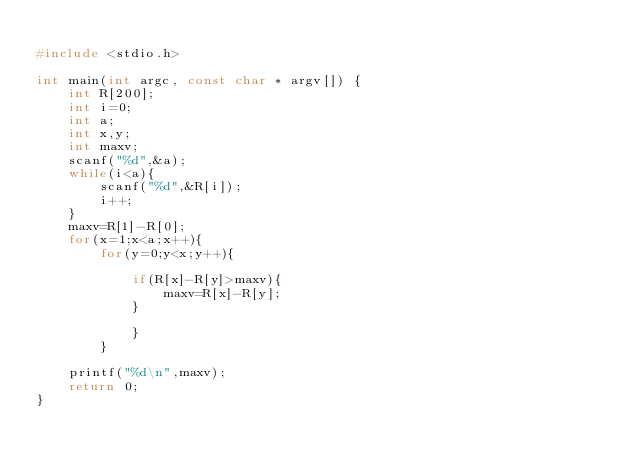Convert code to text. <code><loc_0><loc_0><loc_500><loc_500><_C_>
#include <stdio.h>

int main(int argc, const char * argv[]) {
    int R[200];
    int i=0;
    int a;
    int x,y;
    int maxv;
    scanf("%d",&a);
    while(i<a){
        scanf("%d",&R[i]);
        i++;
    }
    maxv=R[1]-R[0];
    for(x=1;x<a;x++){
        for(y=0;y<x;y++){
        
            if(R[x]-R[y]>maxv){
                maxv=R[x]-R[y];
            }
           
            }
        }
    
    printf("%d\n",maxv);
    return 0;
}</code> 